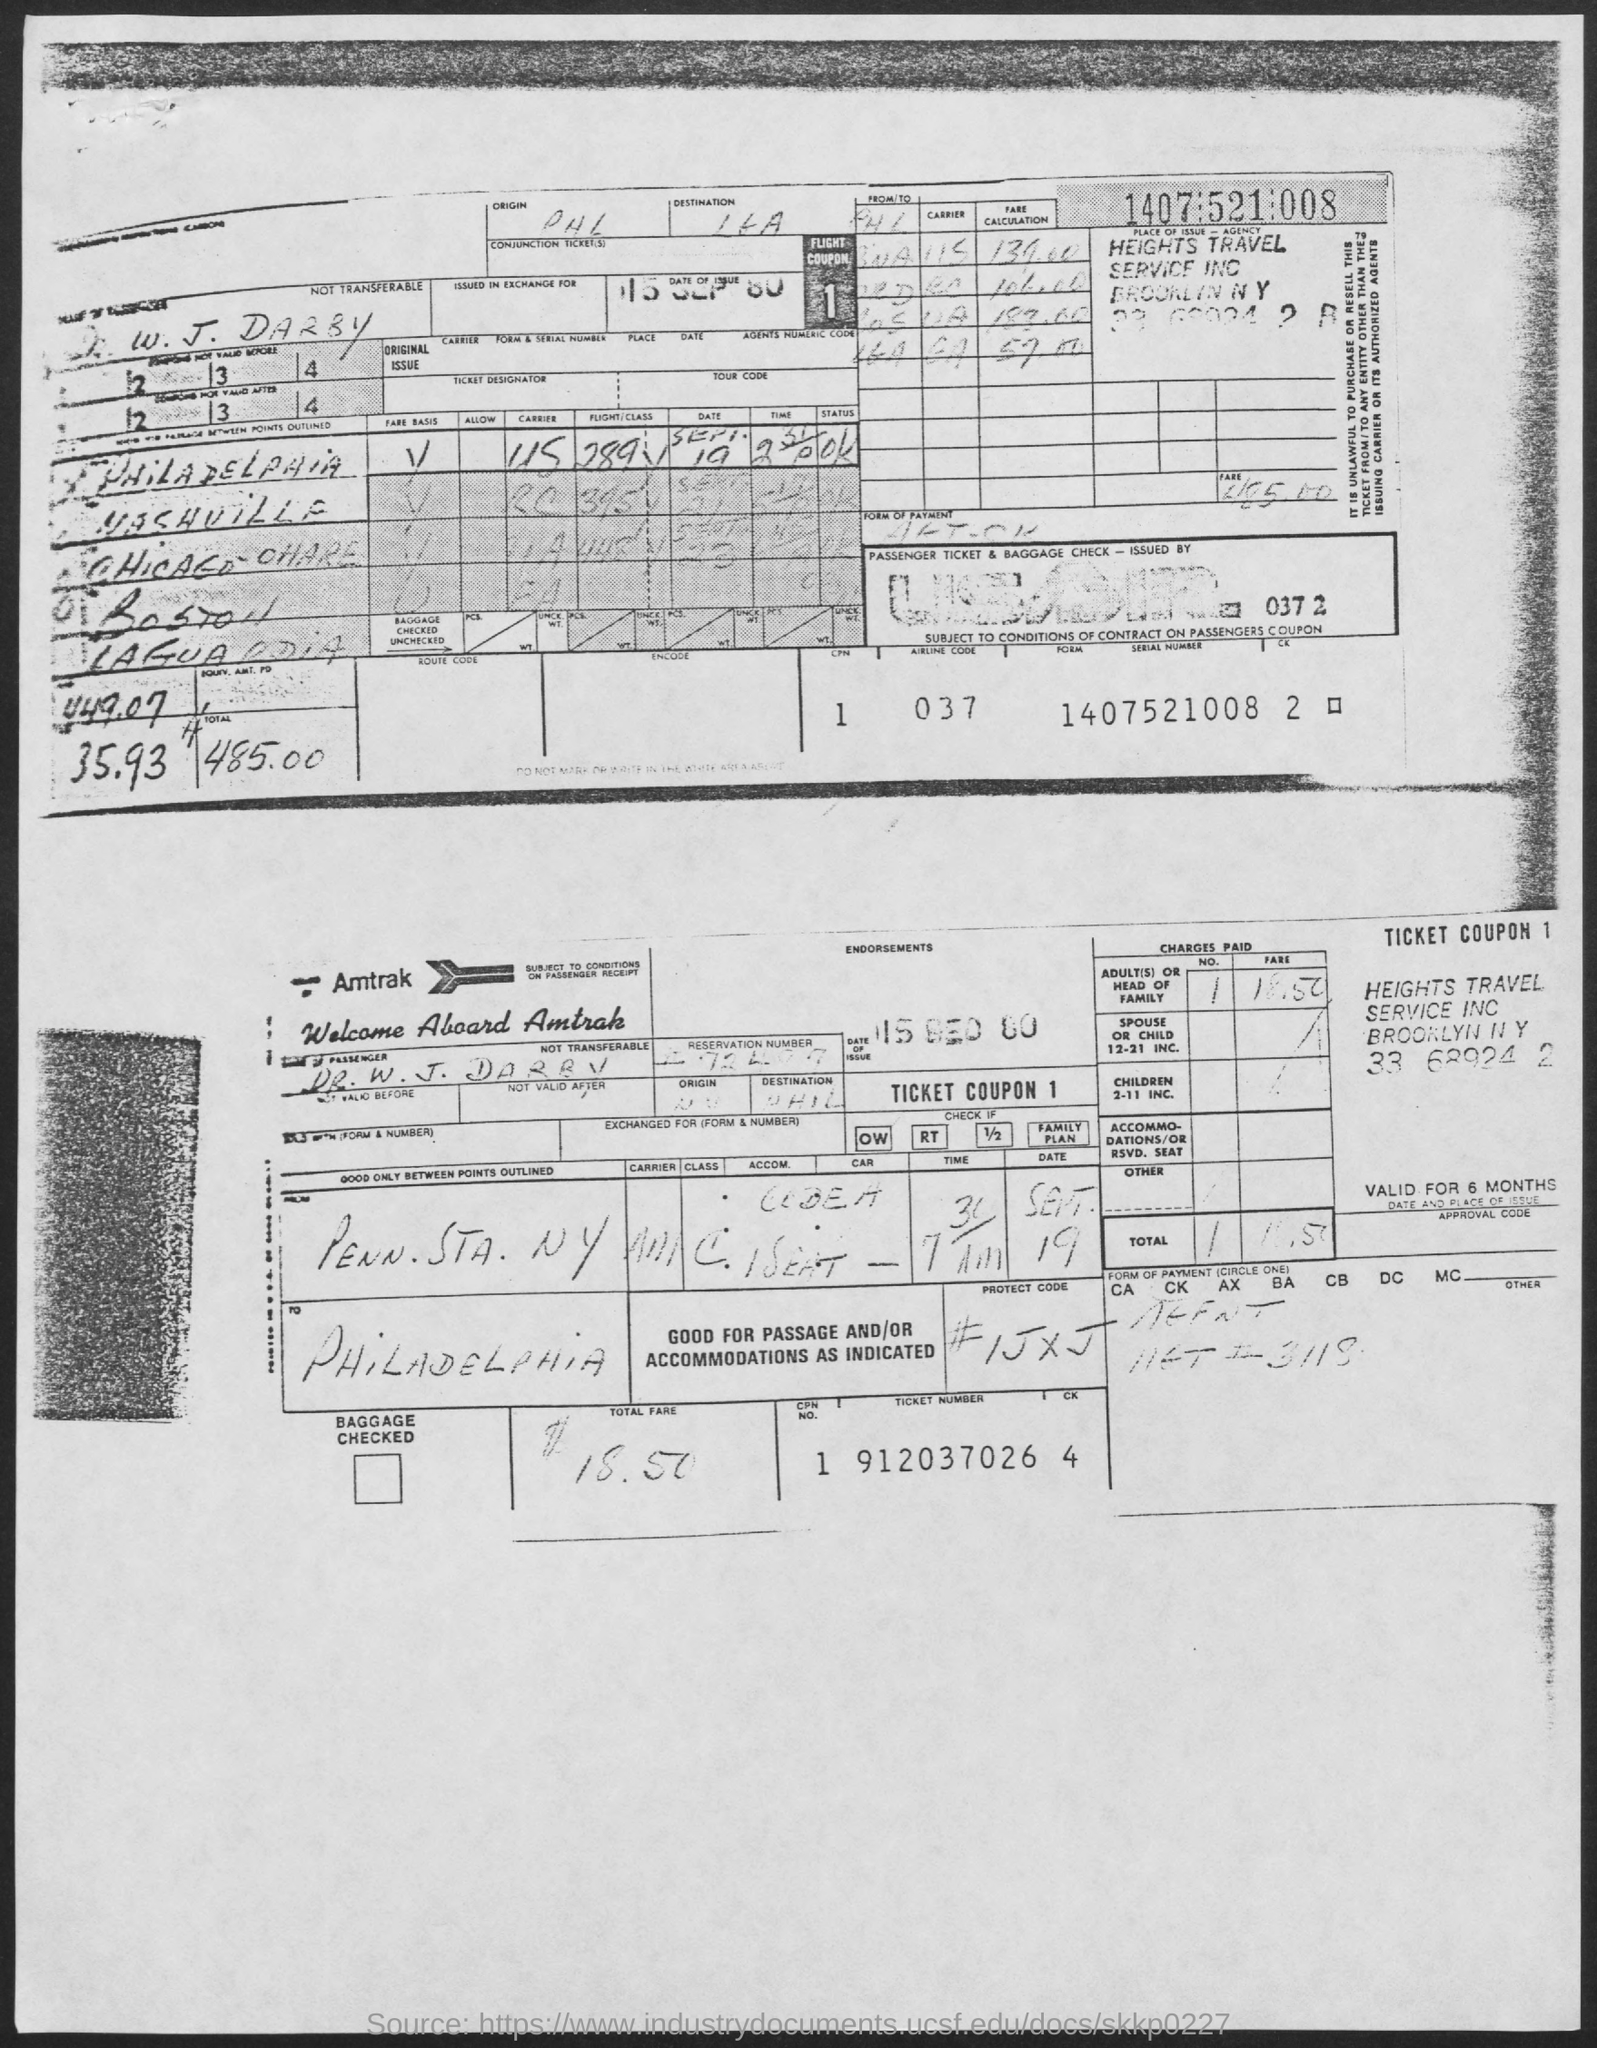Draw attention to some important aspects in this diagram. The ticket number mentioned in the given form is 912037026... The date of issue mentioned in the given form is September 15, 1980. What is the airline code mentioned in the provided form? The code is 037... 